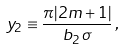Convert formula to latex. <formula><loc_0><loc_0><loc_500><loc_500>y _ { 2 } \equiv \frac { \pi | 2 m + 1 | } { b _ { 2 } \, \sigma } \, ,</formula> 